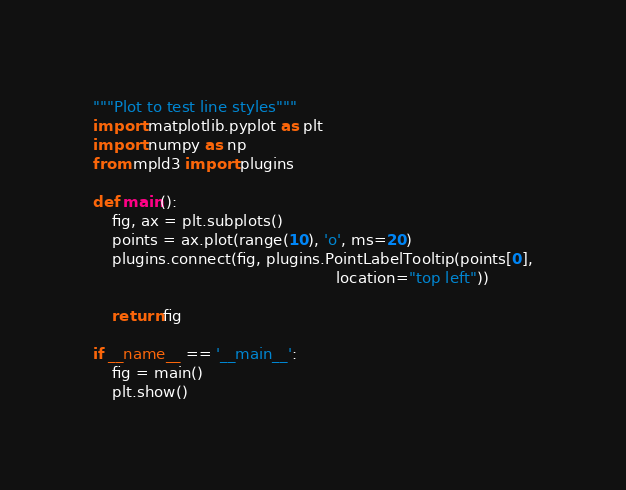Convert code to text. <code><loc_0><loc_0><loc_500><loc_500><_Python_>"""Plot to test line styles"""
import matplotlib.pyplot as plt
import numpy as np
from mpld3 import plugins

def main():
    fig, ax = plt.subplots()
    points = ax.plot(range(10), 'o', ms=20)
    plugins.connect(fig, plugins.PointLabelTooltip(points[0],
                                                   location="top left"))

    return fig

if __name__ == '__main__':
    fig = main()
    plt.show()

</code> 